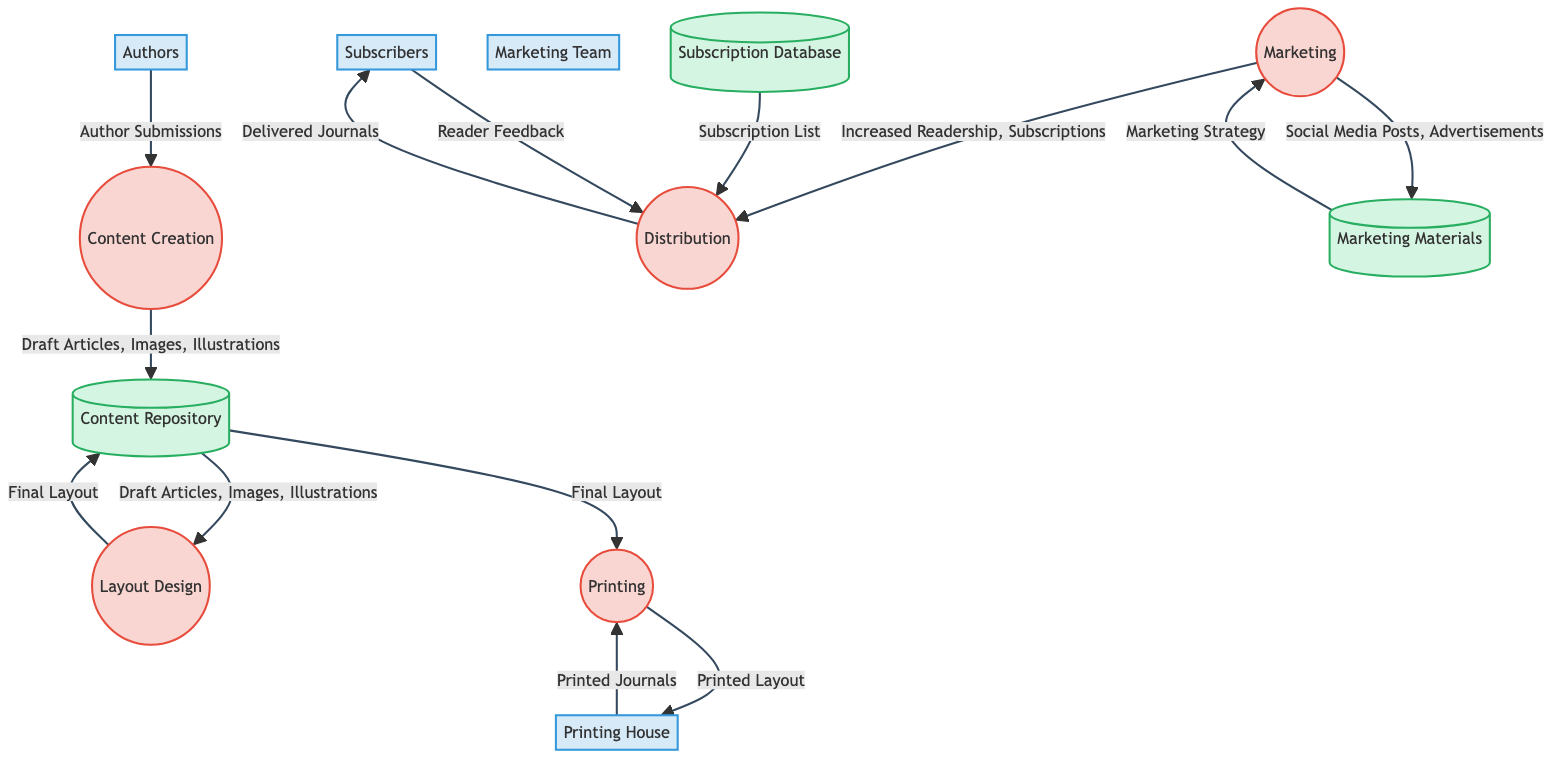What is the first process in the diagram? The first process in the diagram, as indicated by the top flow, is "Content Creation".
Answer: Content Creation How many external entities are present in the diagram? There are four external entities listed: Authors, Printing House, Subscribers, and Marketing Team.
Answer: 4 What are the inputs for the Layout Design process? The Layout Design process requires three inputs: Draft Articles, Images, and Illustrations.
Answer: Draft Articles, Images, Illustrations Which data store receives outputs from the Content Creation process? The Content Creation process outputs Draft Articles, Images, and Illustrations to the Content Repository data store.
Answer: Content Repository What is the output of the Distribution process? The output generated from the Distribution process is "Delivered Journals".
Answer: Delivered Journals Which team is responsible for promoting the journal? The team responsible for promoting the journal is the Marketing Team.
Answer: Marketing Team From which process does the Distribution process receive inputs? The Distribution process receives its inputs from the Marketing process, specifically "Increased Readership" and "Subscriptions".
Answer: Marketing What data flows from the Subscription Database to the Distribution process? The Subscription List flows from the Subscription Database to the Distribution process.
Answer: Subscription List What is the final output of the Printing process? The final output of the Printing process is "Printed Journals".
Answer: Printed Journals 